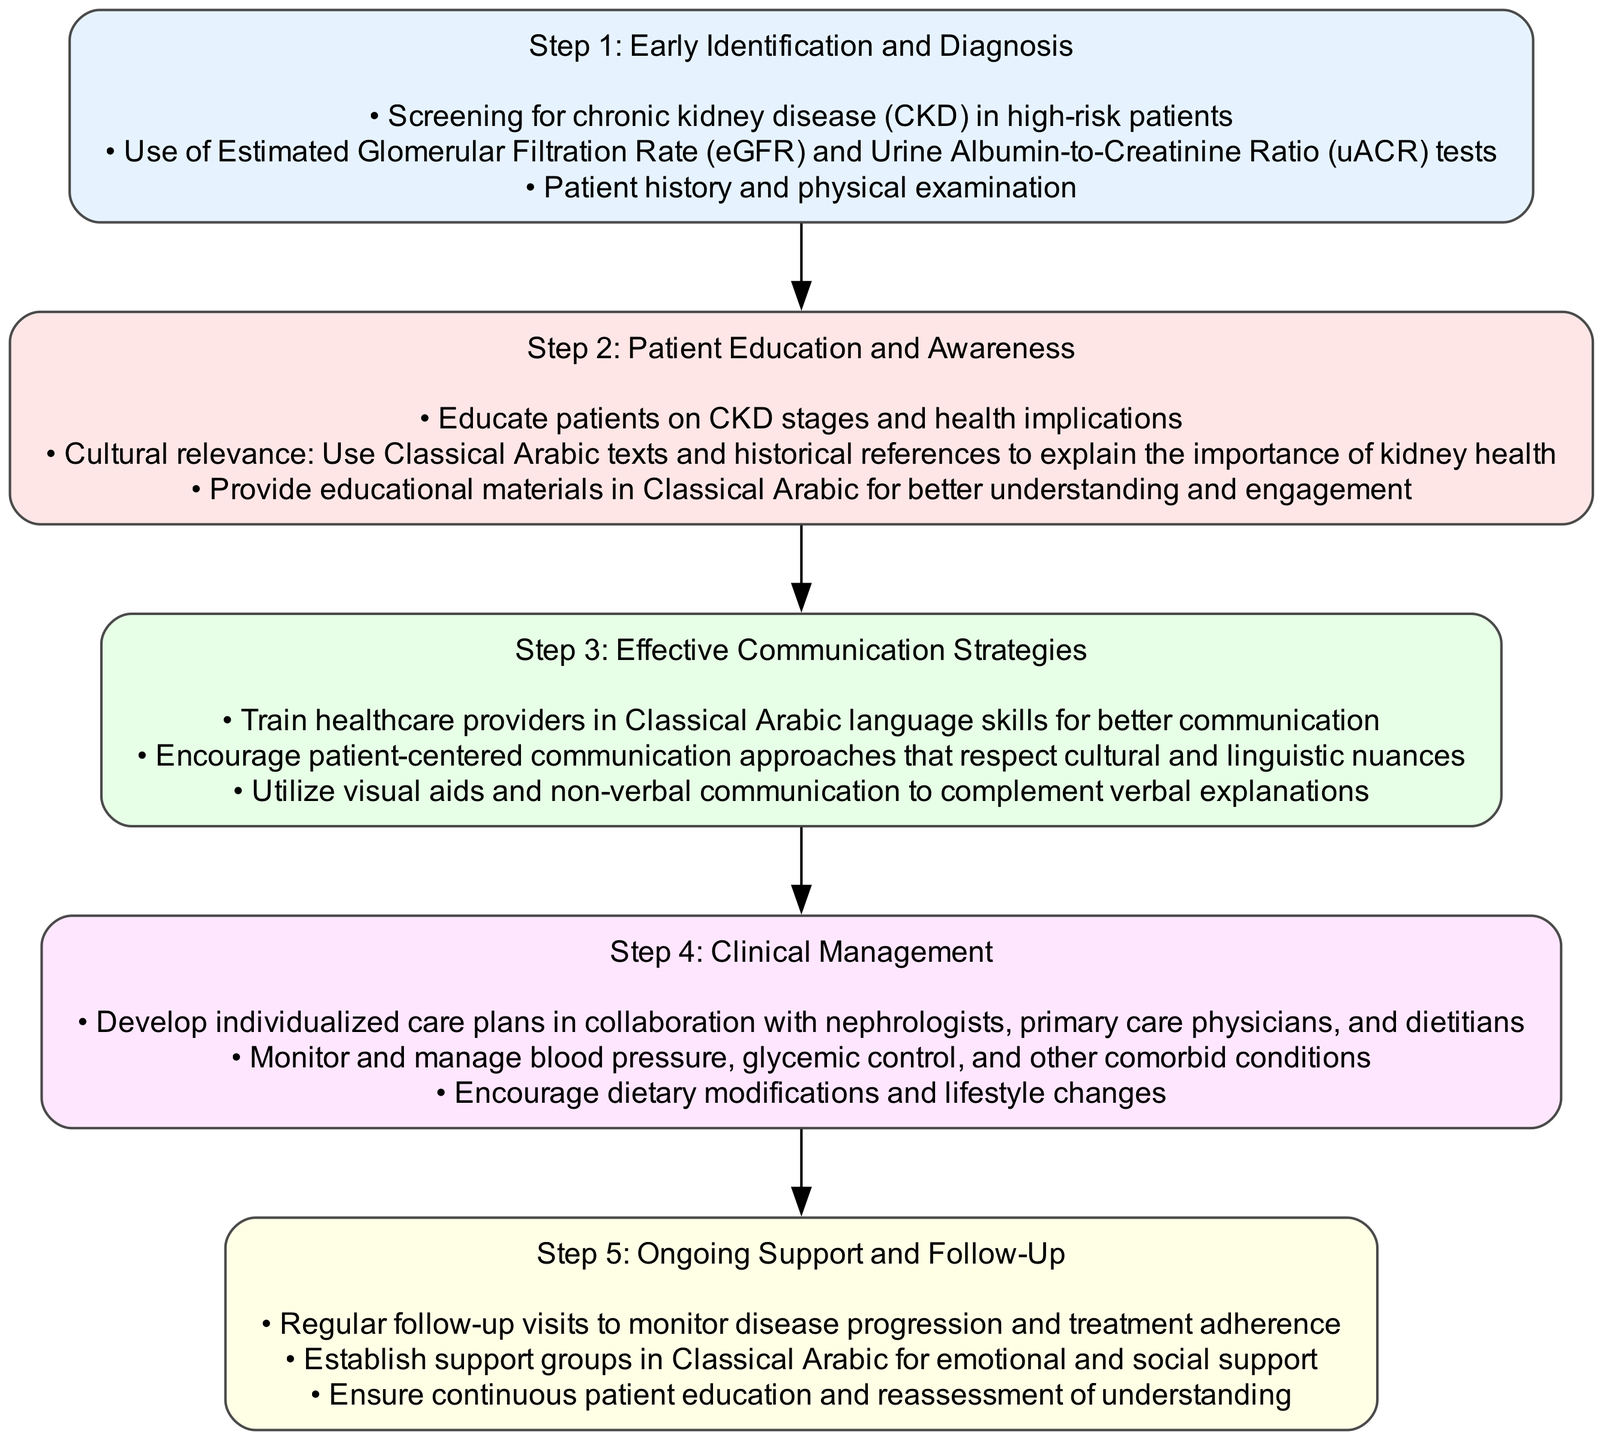ما هي الخطوة الأولى في المسار السريري لإدارة مرض الكلى المزمن؟ الخطوة الأولى في المسار هي "التحديد" وتتضمن التعرف المبكر والتشخيص، حيث يتم فحص المرضى ذوي المخاطر العالية.
Answer: التحديد ما هو الهدف من الخطوة الثانية في هذا المسار؟ الهدف من الخطوة الثانية، وهي "التعليم"، هو توعية المرضى بمراحل مرض الكلى المزمن وأهميته الصحية، مع استخدام نصوص باللغة العربية الفصحى.
Answer: التعليم كم عدد الخطوات الموجودة في المسار السريري؟ يتضمن المسار السريري خمس خطوات: التحديد، التعليم، الاتصال، الإدارة، والدعم.
Answer: خمس خطوات ما هي بعض المهام في خطوة "التعليم"؟ المهام في خطوة "التعليم" تشمل تعليم المرضى عن مراحل مرض الكلى وتقديم المواد التعليمية باللغة العربية الفصحى.
Answer: تعليم المرضى ما هي الاستراتيجيات المستخدمة في الخطوة الثالثة لتحسين الاتصال؟ تشمل الاستراتيجيات في الخطوة الثالثة تدريب مقدمي الرعاية الصحية على مهارات اللغة العربية الفصحى وتعزيز التواصل الموجه نحو المريض.
Answer: تدريب مقدمي الرعاية كيف تتم إدارة الحالة في الخطوة الرابعة؟ في الخطوة الرابعة، يتم تطوير خطط الرعاية الفردية بالتعاون مع الأطباء المختصين وموظفي الحمية، بالإضافة إلى مراقبة الحالات المرافقة.
Answer: تطوير خطط الرعاية الفردية ما أهمية الدعم في الخطوة الخامسة؟ الدعم في الخطوة الخامسة مهم لأنه يتضمن الزيارات المنتظمة لمراقبة تقدم المرض وتشكيل مجموعات دعم باللغة العربية الفصحى لضمان التعليم المستمر.
Answer: المراقبة والمجموعات دعم 